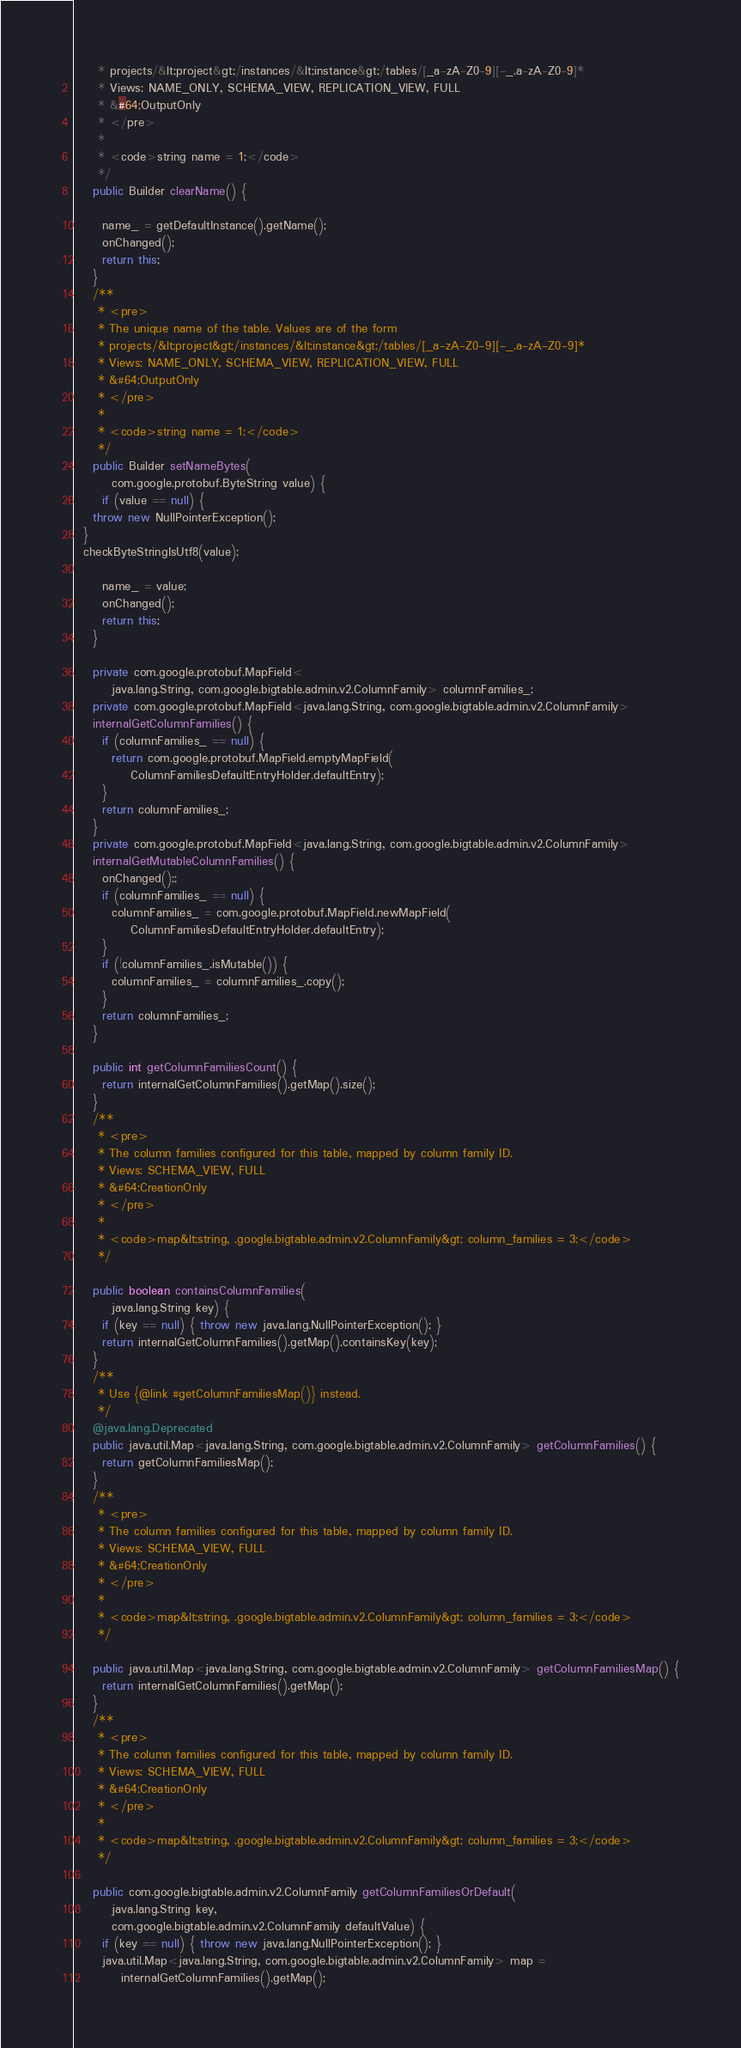<code> <loc_0><loc_0><loc_500><loc_500><_Java_>     * projects/&lt;project&gt;/instances/&lt;instance&gt;/tables/[_a-zA-Z0-9][-_.a-zA-Z0-9]*
     * Views: NAME_ONLY, SCHEMA_VIEW, REPLICATION_VIEW, FULL
     * &#64;OutputOnly
     * </pre>
     *
     * <code>string name = 1;</code>
     */
    public Builder clearName() {
      
      name_ = getDefaultInstance().getName();
      onChanged();
      return this;
    }
    /**
     * <pre>
     * The unique name of the table. Values are of the form
     * projects/&lt;project&gt;/instances/&lt;instance&gt;/tables/[_a-zA-Z0-9][-_.a-zA-Z0-9]*
     * Views: NAME_ONLY, SCHEMA_VIEW, REPLICATION_VIEW, FULL
     * &#64;OutputOnly
     * </pre>
     *
     * <code>string name = 1;</code>
     */
    public Builder setNameBytes(
        com.google.protobuf.ByteString value) {
      if (value == null) {
    throw new NullPointerException();
  }
  checkByteStringIsUtf8(value);
      
      name_ = value;
      onChanged();
      return this;
    }

    private com.google.protobuf.MapField<
        java.lang.String, com.google.bigtable.admin.v2.ColumnFamily> columnFamilies_;
    private com.google.protobuf.MapField<java.lang.String, com.google.bigtable.admin.v2.ColumnFamily>
    internalGetColumnFamilies() {
      if (columnFamilies_ == null) {
        return com.google.protobuf.MapField.emptyMapField(
            ColumnFamiliesDefaultEntryHolder.defaultEntry);
      }
      return columnFamilies_;
    }
    private com.google.protobuf.MapField<java.lang.String, com.google.bigtable.admin.v2.ColumnFamily>
    internalGetMutableColumnFamilies() {
      onChanged();;
      if (columnFamilies_ == null) {
        columnFamilies_ = com.google.protobuf.MapField.newMapField(
            ColumnFamiliesDefaultEntryHolder.defaultEntry);
      }
      if (!columnFamilies_.isMutable()) {
        columnFamilies_ = columnFamilies_.copy();
      }
      return columnFamilies_;
    }

    public int getColumnFamiliesCount() {
      return internalGetColumnFamilies().getMap().size();
    }
    /**
     * <pre>
     * The column families configured for this table, mapped by column family ID.
     * Views: SCHEMA_VIEW, FULL
     * &#64;CreationOnly
     * </pre>
     *
     * <code>map&lt;string, .google.bigtable.admin.v2.ColumnFamily&gt; column_families = 3;</code>
     */

    public boolean containsColumnFamilies(
        java.lang.String key) {
      if (key == null) { throw new java.lang.NullPointerException(); }
      return internalGetColumnFamilies().getMap().containsKey(key);
    }
    /**
     * Use {@link #getColumnFamiliesMap()} instead.
     */
    @java.lang.Deprecated
    public java.util.Map<java.lang.String, com.google.bigtable.admin.v2.ColumnFamily> getColumnFamilies() {
      return getColumnFamiliesMap();
    }
    /**
     * <pre>
     * The column families configured for this table, mapped by column family ID.
     * Views: SCHEMA_VIEW, FULL
     * &#64;CreationOnly
     * </pre>
     *
     * <code>map&lt;string, .google.bigtable.admin.v2.ColumnFamily&gt; column_families = 3;</code>
     */

    public java.util.Map<java.lang.String, com.google.bigtable.admin.v2.ColumnFamily> getColumnFamiliesMap() {
      return internalGetColumnFamilies().getMap();
    }
    /**
     * <pre>
     * The column families configured for this table, mapped by column family ID.
     * Views: SCHEMA_VIEW, FULL
     * &#64;CreationOnly
     * </pre>
     *
     * <code>map&lt;string, .google.bigtable.admin.v2.ColumnFamily&gt; column_families = 3;</code>
     */

    public com.google.bigtable.admin.v2.ColumnFamily getColumnFamiliesOrDefault(
        java.lang.String key,
        com.google.bigtable.admin.v2.ColumnFamily defaultValue) {
      if (key == null) { throw new java.lang.NullPointerException(); }
      java.util.Map<java.lang.String, com.google.bigtable.admin.v2.ColumnFamily> map =
          internalGetColumnFamilies().getMap();</code> 